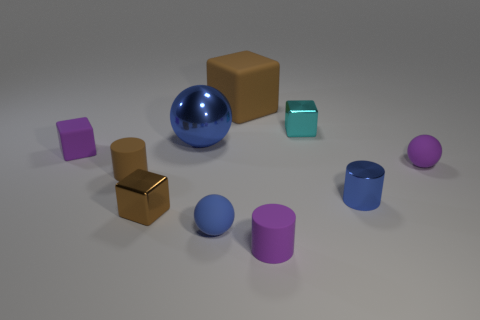How many brown metallic objects are the same size as the brown cylinder? There appears to be one brown metallic cube that is approximately the same size as the brown cylinder in the image. 